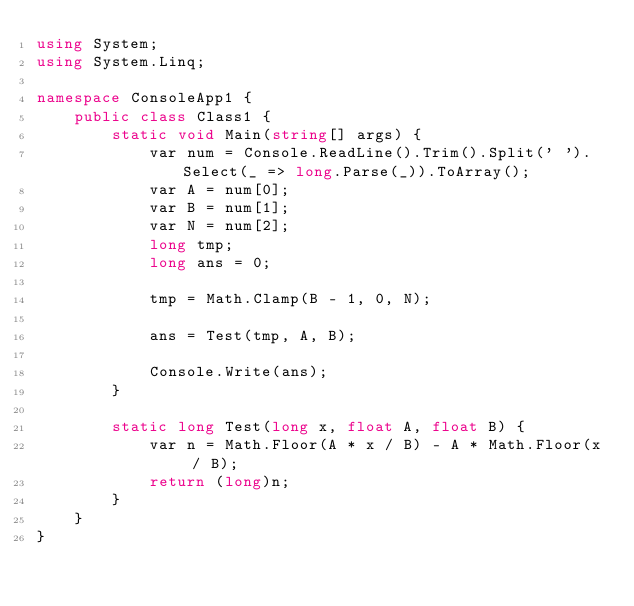Convert code to text. <code><loc_0><loc_0><loc_500><loc_500><_C#_>using System;
using System.Linq;

namespace ConsoleApp1 {
    public class Class1 {
        static void Main(string[] args) {
            var num = Console.ReadLine().Trim().Split(' ').Select(_ => long.Parse(_)).ToArray();
            var A = num[0];
            var B = num[1];
            var N = num[2];
            long tmp;
            long ans = 0;

            tmp = Math.Clamp(B - 1, 0, N);
            
            ans = Test(tmp, A, B);

            Console.Write(ans);
        }

        static long Test(long x, float A, float B) {
            var n = Math.Floor(A * x / B) - A * Math.Floor(x / B);
            return (long)n;
        }
    }
}</code> 